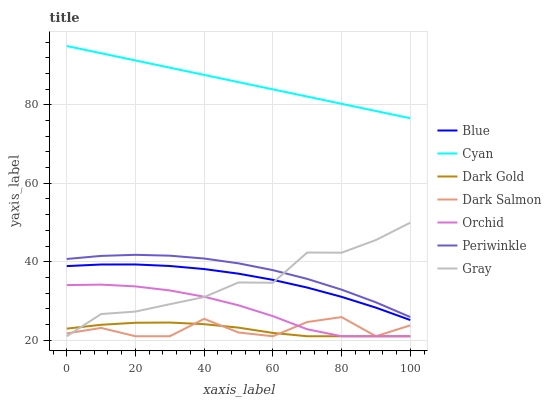Does Dark Gold have the minimum area under the curve?
Answer yes or no. Yes. Does Cyan have the maximum area under the curve?
Answer yes or no. Yes. Does Gray have the minimum area under the curve?
Answer yes or no. No. Does Gray have the maximum area under the curve?
Answer yes or no. No. Is Cyan the smoothest?
Answer yes or no. Yes. Is Dark Salmon the roughest?
Answer yes or no. Yes. Is Gray the smoothest?
Answer yes or no. No. Is Gray the roughest?
Answer yes or no. No. Does Gray have the lowest value?
Answer yes or no. Yes. Does Periwinkle have the lowest value?
Answer yes or no. No. Does Cyan have the highest value?
Answer yes or no. Yes. Does Gray have the highest value?
Answer yes or no. No. Is Orchid less than Blue?
Answer yes or no. Yes. Is Blue greater than Dark Salmon?
Answer yes or no. Yes. Does Gray intersect Blue?
Answer yes or no. Yes. Is Gray less than Blue?
Answer yes or no. No. Is Gray greater than Blue?
Answer yes or no. No. Does Orchid intersect Blue?
Answer yes or no. No. 